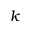Convert formula to latex. <formula><loc_0><loc_0><loc_500><loc_500>k</formula> 